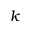Convert formula to latex. <formula><loc_0><loc_0><loc_500><loc_500>k</formula> 